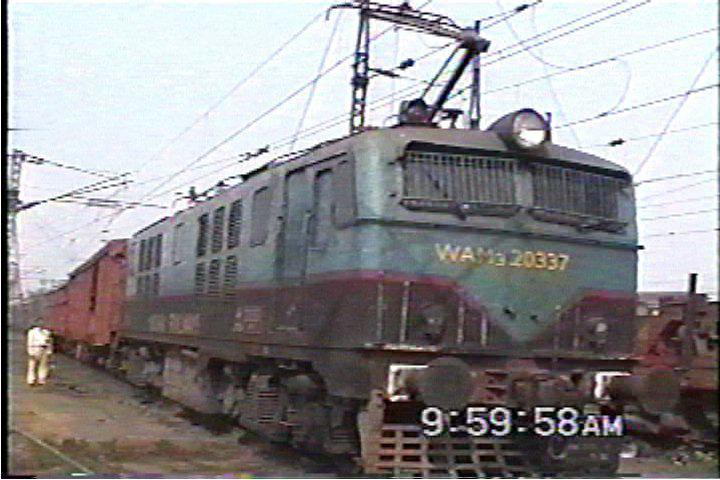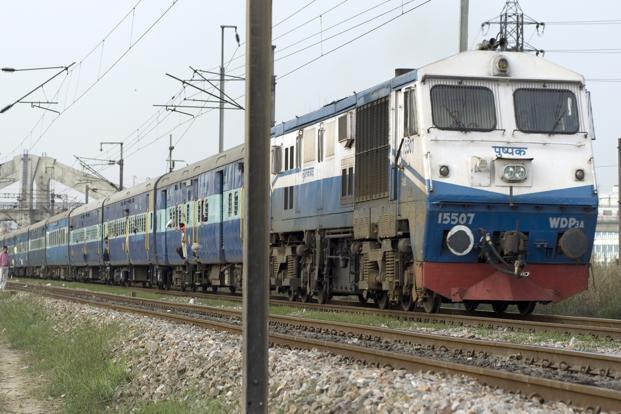The first image is the image on the left, the second image is the image on the right. Given the left and right images, does the statement "There are two trains going in the same direction, none of which are red." hold true? Answer yes or no. Yes. The first image is the image on the left, the second image is the image on the right. Analyze the images presented: Is the assertion "A red train with a yellowish stripe running its length is angled facing rightward." valid? Answer yes or no. No. 